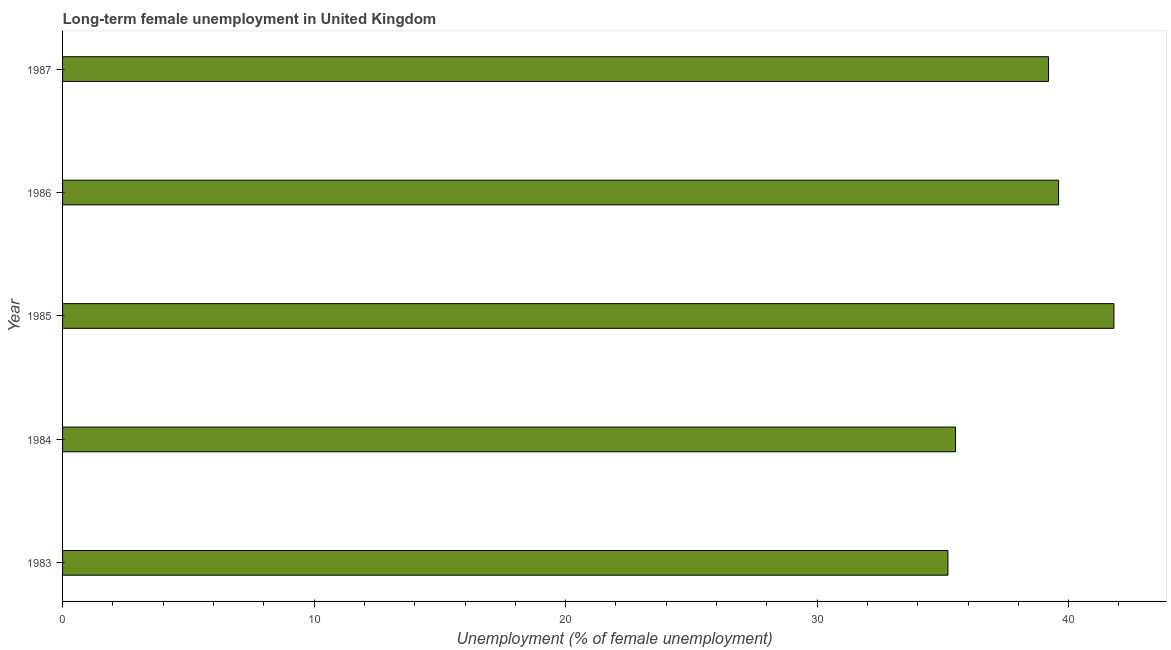Does the graph contain any zero values?
Offer a very short reply. No. Does the graph contain grids?
Keep it short and to the point. No. What is the title of the graph?
Your answer should be compact. Long-term female unemployment in United Kingdom. What is the label or title of the X-axis?
Your response must be concise. Unemployment (% of female unemployment). What is the label or title of the Y-axis?
Make the answer very short. Year. What is the long-term female unemployment in 1984?
Your response must be concise. 35.5. Across all years, what is the maximum long-term female unemployment?
Provide a succinct answer. 41.8. Across all years, what is the minimum long-term female unemployment?
Ensure brevity in your answer.  35.2. In which year was the long-term female unemployment minimum?
Provide a short and direct response. 1983. What is the sum of the long-term female unemployment?
Offer a terse response. 191.3. What is the average long-term female unemployment per year?
Your response must be concise. 38.26. What is the median long-term female unemployment?
Your response must be concise. 39.2. Do a majority of the years between 1986 and 1987 (inclusive) have long-term female unemployment greater than 24 %?
Offer a terse response. Yes. What is the ratio of the long-term female unemployment in 1984 to that in 1986?
Your answer should be compact. 0.9. Is the long-term female unemployment in 1983 less than that in 1987?
Provide a succinct answer. Yes. What is the difference between the highest and the second highest long-term female unemployment?
Your answer should be compact. 2.2. In how many years, is the long-term female unemployment greater than the average long-term female unemployment taken over all years?
Keep it short and to the point. 3. Are the values on the major ticks of X-axis written in scientific E-notation?
Provide a short and direct response. No. What is the Unemployment (% of female unemployment) in 1983?
Offer a terse response. 35.2. What is the Unemployment (% of female unemployment) of 1984?
Ensure brevity in your answer.  35.5. What is the Unemployment (% of female unemployment) in 1985?
Provide a short and direct response. 41.8. What is the Unemployment (% of female unemployment) in 1986?
Keep it short and to the point. 39.6. What is the Unemployment (% of female unemployment) of 1987?
Give a very brief answer. 39.2. What is the difference between the Unemployment (% of female unemployment) in 1983 and 1984?
Provide a short and direct response. -0.3. What is the difference between the Unemployment (% of female unemployment) in 1983 and 1985?
Provide a succinct answer. -6.6. What is the difference between the Unemployment (% of female unemployment) in 1983 and 1987?
Provide a short and direct response. -4. What is the difference between the Unemployment (% of female unemployment) in 1984 and 1987?
Your response must be concise. -3.7. What is the ratio of the Unemployment (% of female unemployment) in 1983 to that in 1985?
Ensure brevity in your answer.  0.84. What is the ratio of the Unemployment (% of female unemployment) in 1983 to that in 1986?
Make the answer very short. 0.89. What is the ratio of the Unemployment (% of female unemployment) in 1983 to that in 1987?
Make the answer very short. 0.9. What is the ratio of the Unemployment (% of female unemployment) in 1984 to that in 1985?
Ensure brevity in your answer.  0.85. What is the ratio of the Unemployment (% of female unemployment) in 1984 to that in 1986?
Make the answer very short. 0.9. What is the ratio of the Unemployment (% of female unemployment) in 1984 to that in 1987?
Make the answer very short. 0.91. What is the ratio of the Unemployment (% of female unemployment) in 1985 to that in 1986?
Offer a very short reply. 1.06. What is the ratio of the Unemployment (% of female unemployment) in 1985 to that in 1987?
Make the answer very short. 1.07. 